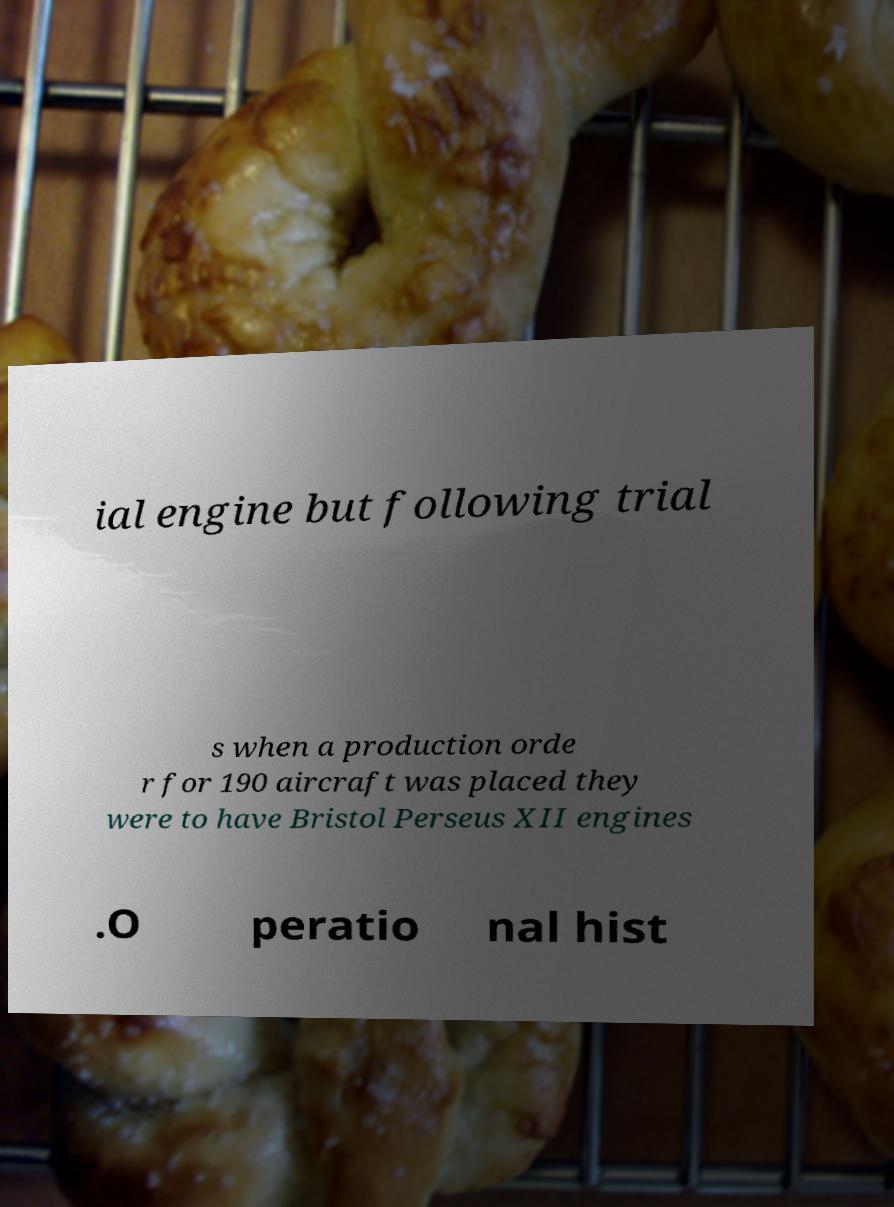I need the written content from this picture converted into text. Can you do that? ial engine but following trial s when a production orde r for 190 aircraft was placed they were to have Bristol Perseus XII engines .O peratio nal hist 